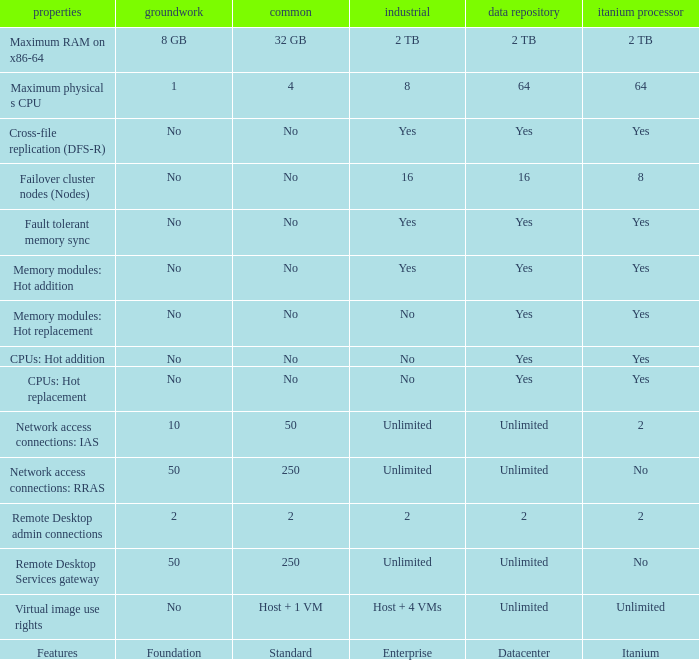Which characteristics are marked as "yes" under the datacenter section? Cross-file replication (DFS-R), Fault tolerant memory sync, Memory modules: Hot addition, Memory modules: Hot replacement, CPUs: Hot addition, CPUs: Hot replacement. 